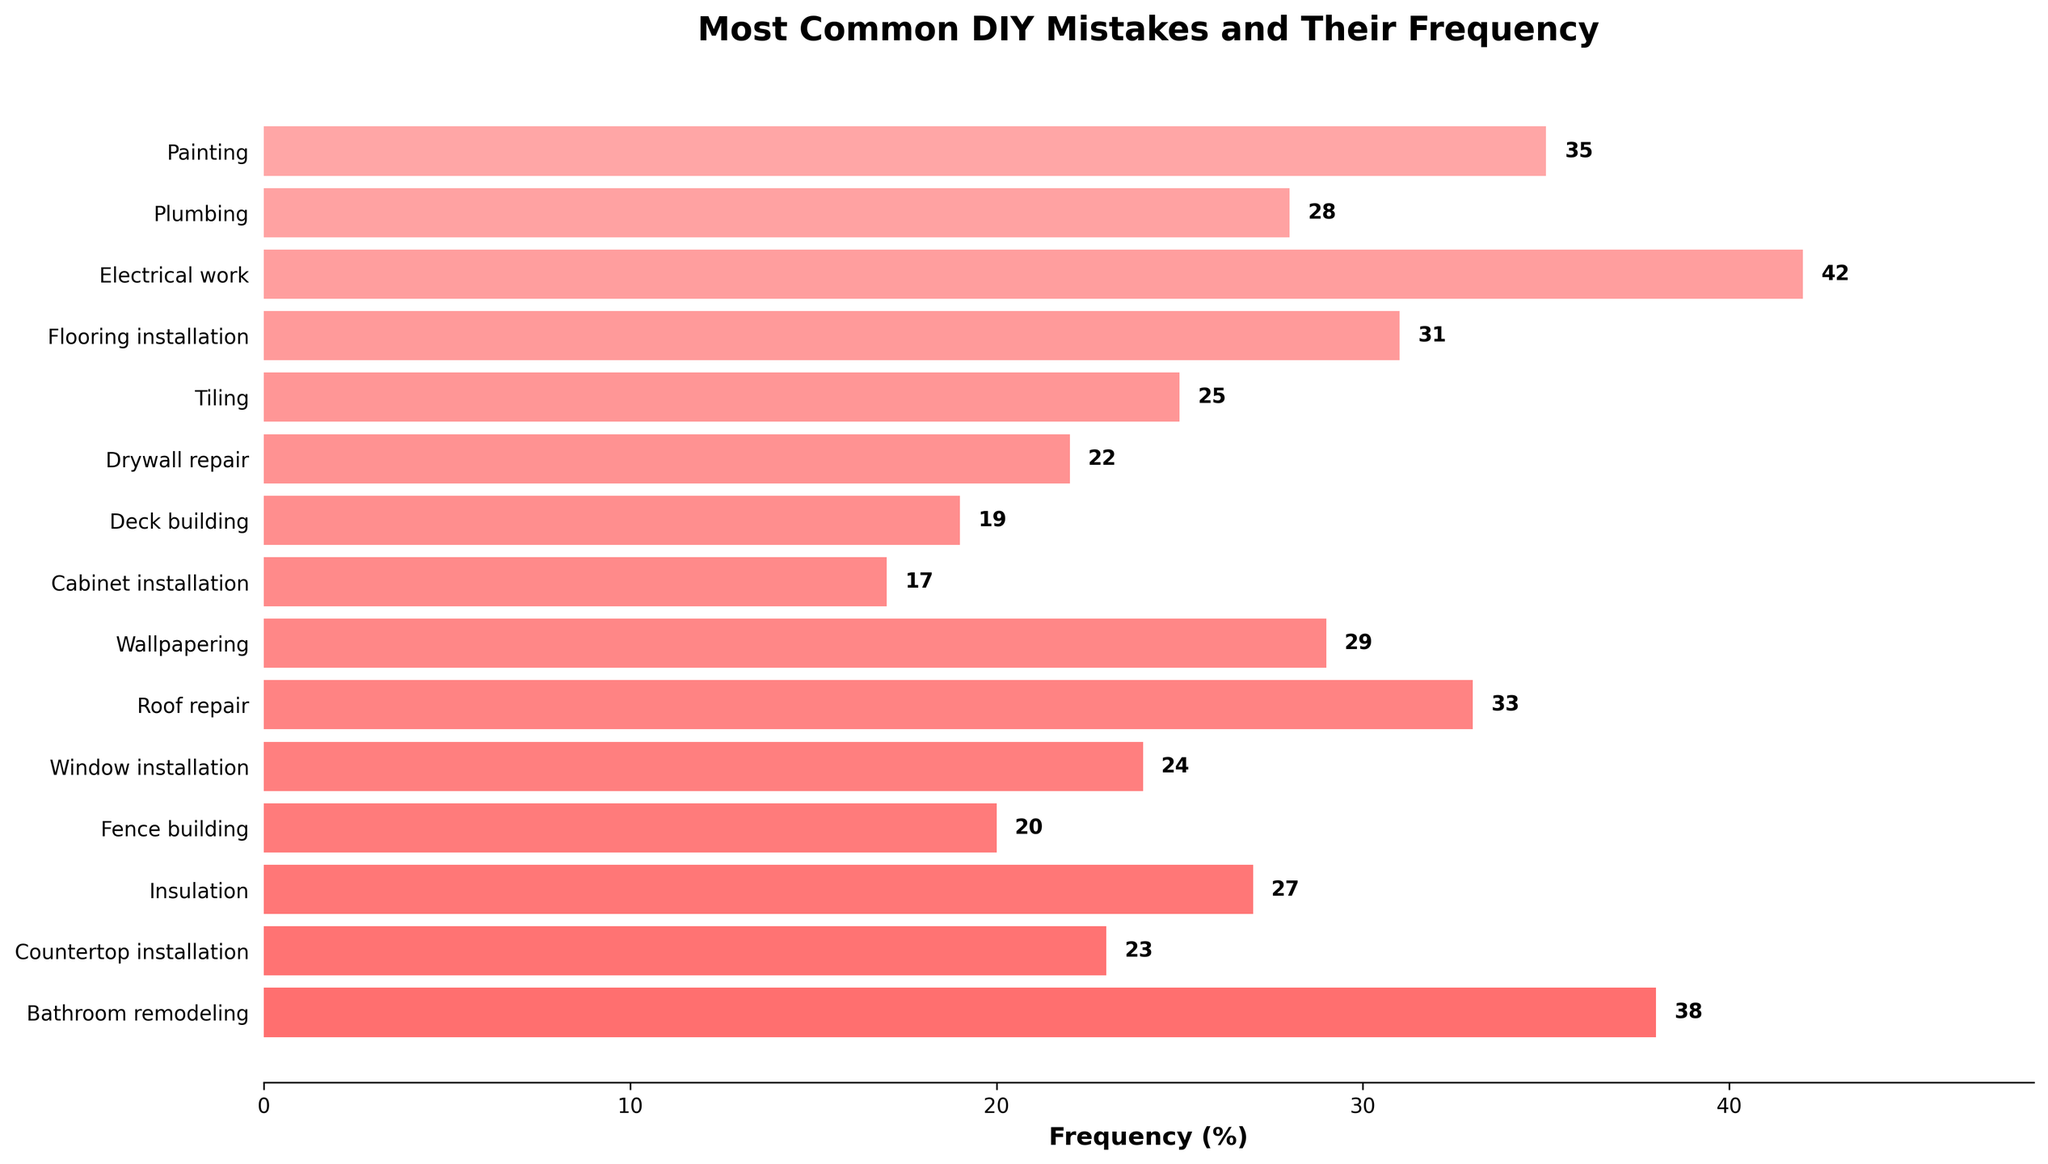What's the most common DIY mistake reported in the figure? The tallest bar in the bar chart represents the most common DIY mistake. The bar for "Incorrect wire connections in Electrical work" is the tallest.
Answer: Incorrect wire connections in Electrical work Which DIY task has the lowest frequency of mistakes? The shortest bar represents the DIY task with the lowest frequency of mistakes. The shortest bar is for "Misaligned cabinet doors in Cabinet installation" with a frequency of 17%.
Answer: Cabinet installation What is the difference in frequency between Painting and Plumbing mistakes? Identify the frequencies of the mistakes for Painting (35%) and Plumbing (28%) and subtract the smaller value from the larger one: 35% - 28% = 7%.
Answer: 7% What is the total frequency of mistakes related to Flooring installation and Deck building combined? Sum the frequencies of mistakes for Flooring installation (31%) and Deck building (19%): 31% + 19% = 50%.
Answer: 50% Is the frequency of mistakes in Bathroom remodeling greater than or less than Tiling mistakes? Compare the lengths of the bars for Bathroom remodeling (38%) and Tiling (25%). The Bathroom remodeling bar is longer, indicating a higher frequency.
Answer: Greater How much more frequent are mistakes in Insulation than in Drywall repair? The frequencies for Insulation (27%) and Drywall repair (22%) are identified, then subtract the smaller value from the larger: 27% - 22% = 5%.
Answer: 5% Which two tasks have mistake frequencies closest to each other? Compare the mistake frequencies across all tasks and find the smallest difference: Fence building (20%) and Deck building (19%) differ by only 1%.
Answer: Fence building and Deck building What is the combined frequency of mistakes for both Electrical work and Roof repair? Sum the frequencies for Electrical work (42%) and Roof repair (33%): 42% + 33% = 75%.
Answer: 75% How does the frequency of mistakes in Painting compare to that in Wallpapering? Compare the lengths of the bars for mistakes in Painting (35%) and Wallpapering (29%). The Painting bar is longer, indicating a higher frequency.
Answer: Greater What is the average frequency of mistakes in the tasks listed? Sum all the frequencies and divide by the number of tasks: (35 + 28 + 42 + 31 + 25 + 22 + 19 + 17 + 29 + 33 + 24 + 20 + 27 + 23 + 38)/15 = 28.
Answer: 28 